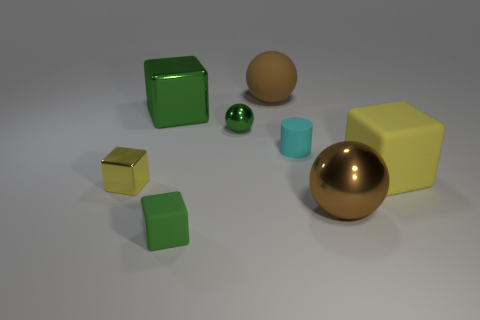Is there any other thing that has the same shape as the small cyan rubber object?
Your answer should be very brief. No. There is a big cube that is behind the small green shiny sphere; is there a small object on the left side of it?
Provide a succinct answer. Yes. There is a big metal object to the right of the small cyan rubber object; is its color the same as the rubber object behind the big green shiny block?
Offer a terse response. Yes. What number of brown balls are the same size as the green rubber thing?
Your response must be concise. 0. There is a yellow block left of the brown matte sphere; does it have the same size as the brown metal thing?
Offer a very short reply. No. There is a tiny cyan rubber object; what shape is it?
Keep it short and to the point. Cylinder. There is a rubber object that is the same color as the big shiny block; what size is it?
Give a very brief answer. Small. Is the yellow block in front of the yellow matte block made of the same material as the small green cube?
Offer a very short reply. No. Are there any balls of the same color as the tiny matte block?
Make the answer very short. Yes. Does the brown shiny thing that is behind the green matte thing have the same shape as the tiny thing to the right of the big brown matte thing?
Ensure brevity in your answer.  No. 